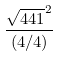<formula> <loc_0><loc_0><loc_500><loc_500>\frac { \sqrt { 4 4 1 } ^ { 2 } } { ( 4 / 4 ) }</formula> 